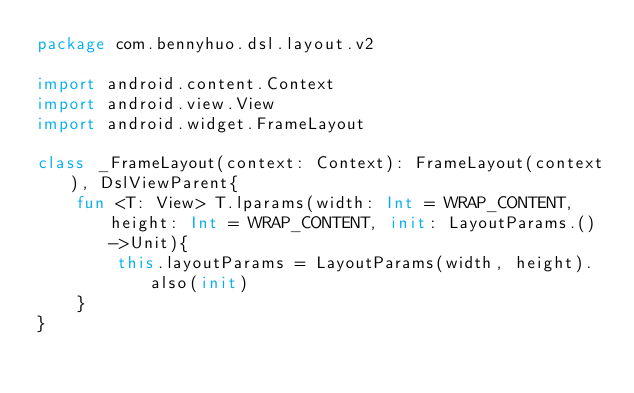Convert code to text. <code><loc_0><loc_0><loc_500><loc_500><_Kotlin_>package com.bennyhuo.dsl.layout.v2

import android.content.Context
import android.view.View
import android.widget.FrameLayout

class _FrameLayout(context: Context): FrameLayout(context), DslViewParent{
    fun <T: View> T.lparams(width: Int = WRAP_CONTENT, height: Int = WRAP_CONTENT, init: LayoutParams.()->Unit){
        this.layoutParams = LayoutParams(width, height).also(init)
    }
}</code> 